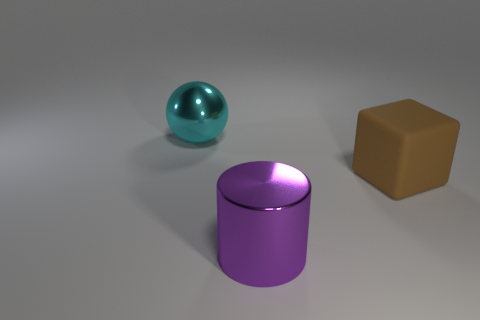How many things are big yellow metal things or objects behind the matte block?
Provide a succinct answer. 1. Are there any other big rubber things that have the same shape as the rubber object?
Your answer should be very brief. No. Are there an equal number of matte blocks that are on the left side of the big cyan metal object and big cyan balls that are behind the brown block?
Your answer should be compact. No. Is there any other thing that is the same size as the cyan ball?
Offer a very short reply. Yes. How many brown things are either big things or spheres?
Make the answer very short. 1. What number of cyan spheres are the same size as the rubber block?
Offer a terse response. 1. There is a object that is left of the brown object and behind the big purple cylinder; what color is it?
Make the answer very short. Cyan. Are there more shiny spheres in front of the big purple shiny thing than large gray matte balls?
Ensure brevity in your answer.  No. Are any shiny objects visible?
Make the answer very short. Yes. Is the color of the big rubber block the same as the metal sphere?
Make the answer very short. No. 